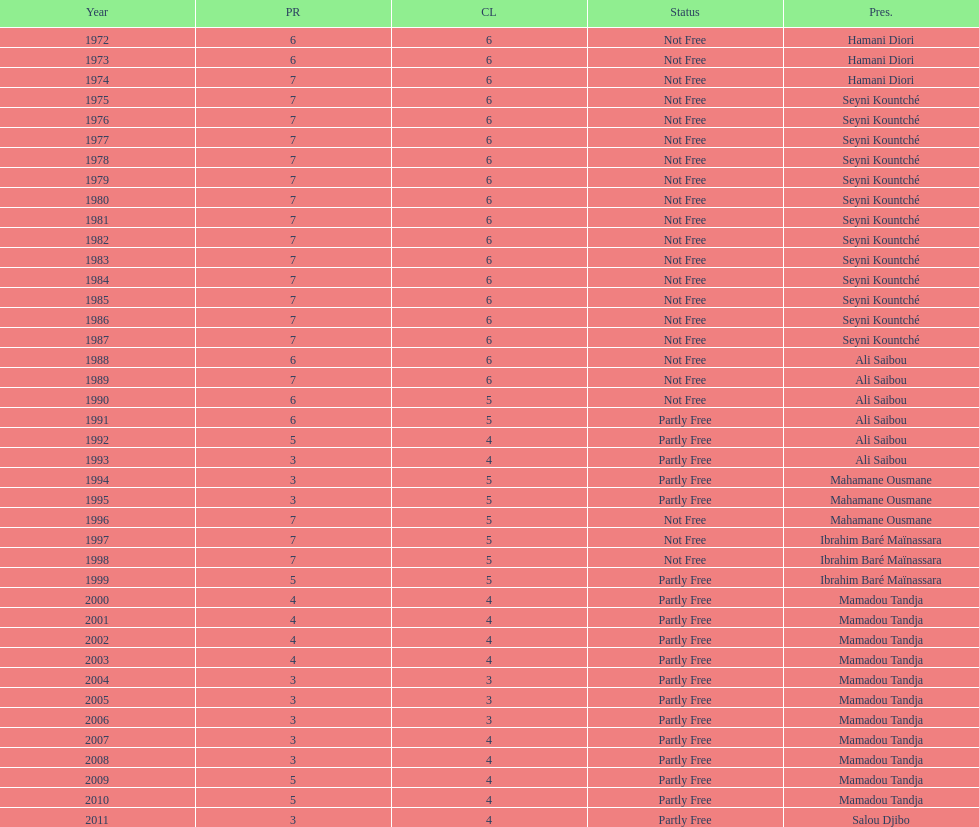What is the number of time seyni kountche has been president? 13. 